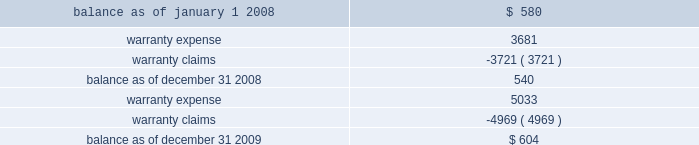Investments prior to our acquisition of keystone on october 12 , 2007 , we held common shares of keystone , which were classified as an available-for-sale investment security .
Accordingly , the investment was included in other assets at its fair value , with the unrealized gain excluded from earnings and included in accumulated other comprehensive income , net of applicable taxes .
Upon our acquisition of keystone on october 12 , 2007 , the unrealized gain was removed from accumulated other comprehensive income , net of applicable taxes , and the original cost of the common shares was considered a component of the purchase price .
Fair value of financial instruments our debt is reflected on the balance sheet at cost .
Based on current market conditions , our interest rate margins are below the rate available in the market , which causes the fair value of our debt to fall below the carrying value .
The fair value of our term loans ( see note 6 , 201clong-term obligations 201d ) is approximately $ 570 million at december 31 , 2009 , as compared to the carrying value of $ 596 million .
We estimated the fair value of our term loans by calculating the upfront cash payment a market participant would require to assume our obligations .
The upfront cash payment , excluding any issuance costs , is the amount that a market participant would be able to lend at december 31 , 2009 to an entity with a credit rating similar to ours and achieve sufficient cash inflows to cover the scheduled cash outflows under our term loans .
The carrying amounts of our cash and equivalents , net trade receivables and accounts payable approximate fair value .
We apply the market approach to value our financial assets and liabilities , which include the cash surrender value of life insurance , deferred compensation liabilities and interest rate swaps .
The market approach utilizes available market information to estimate fair value .
Required fair value disclosures are included in note 8 , 201cfair value measurements . 201d accrued expenses we self-insure a portion of employee medical benefits under the terms of our employee health insurance program .
We purchase certain stop-loss insurance to limit our liability exposure .
We also self-insure a portion of our property and casualty risk , which includes automobile liability , general liability , workers 2019 compensation and property under deductible insurance programs .
The insurance premium costs are expensed over the contract periods .
A reserve for liabilities associated with these losses is established for claims filed and claims incurred but not yet reported based upon our estimate of ultimate cost , which is calculated using analyses of historical data .
We monitor new claims and claim development as well as trends related to the claims incurred but not reported in order to assess the adequacy of our insurance reserves .
Self-insurance reserves on the consolidated balance sheets are net of claims deposits of $ 0.7 million and $ 0.8 million , at december 31 , 2009 and 2008 , respectively .
While we do not expect the amounts ultimately paid to differ significantly from our estimates , our insurance reserves and corresponding expenses could be affected if future claim experience differs significantly from historical trends and assumptions .
Product warranties some of our mechanical products are sold with a standard six-month warranty against defects .
We record the estimated warranty costs at the time of sale using historical warranty claim information to project future warranty claims activity and related expenses .
The changes in the warranty reserve are as follows ( in thousands ) : .

What was the change in warranty reserves from 2008 to 2009? 
Computations: (604 - 540)
Answer: 64.0. 